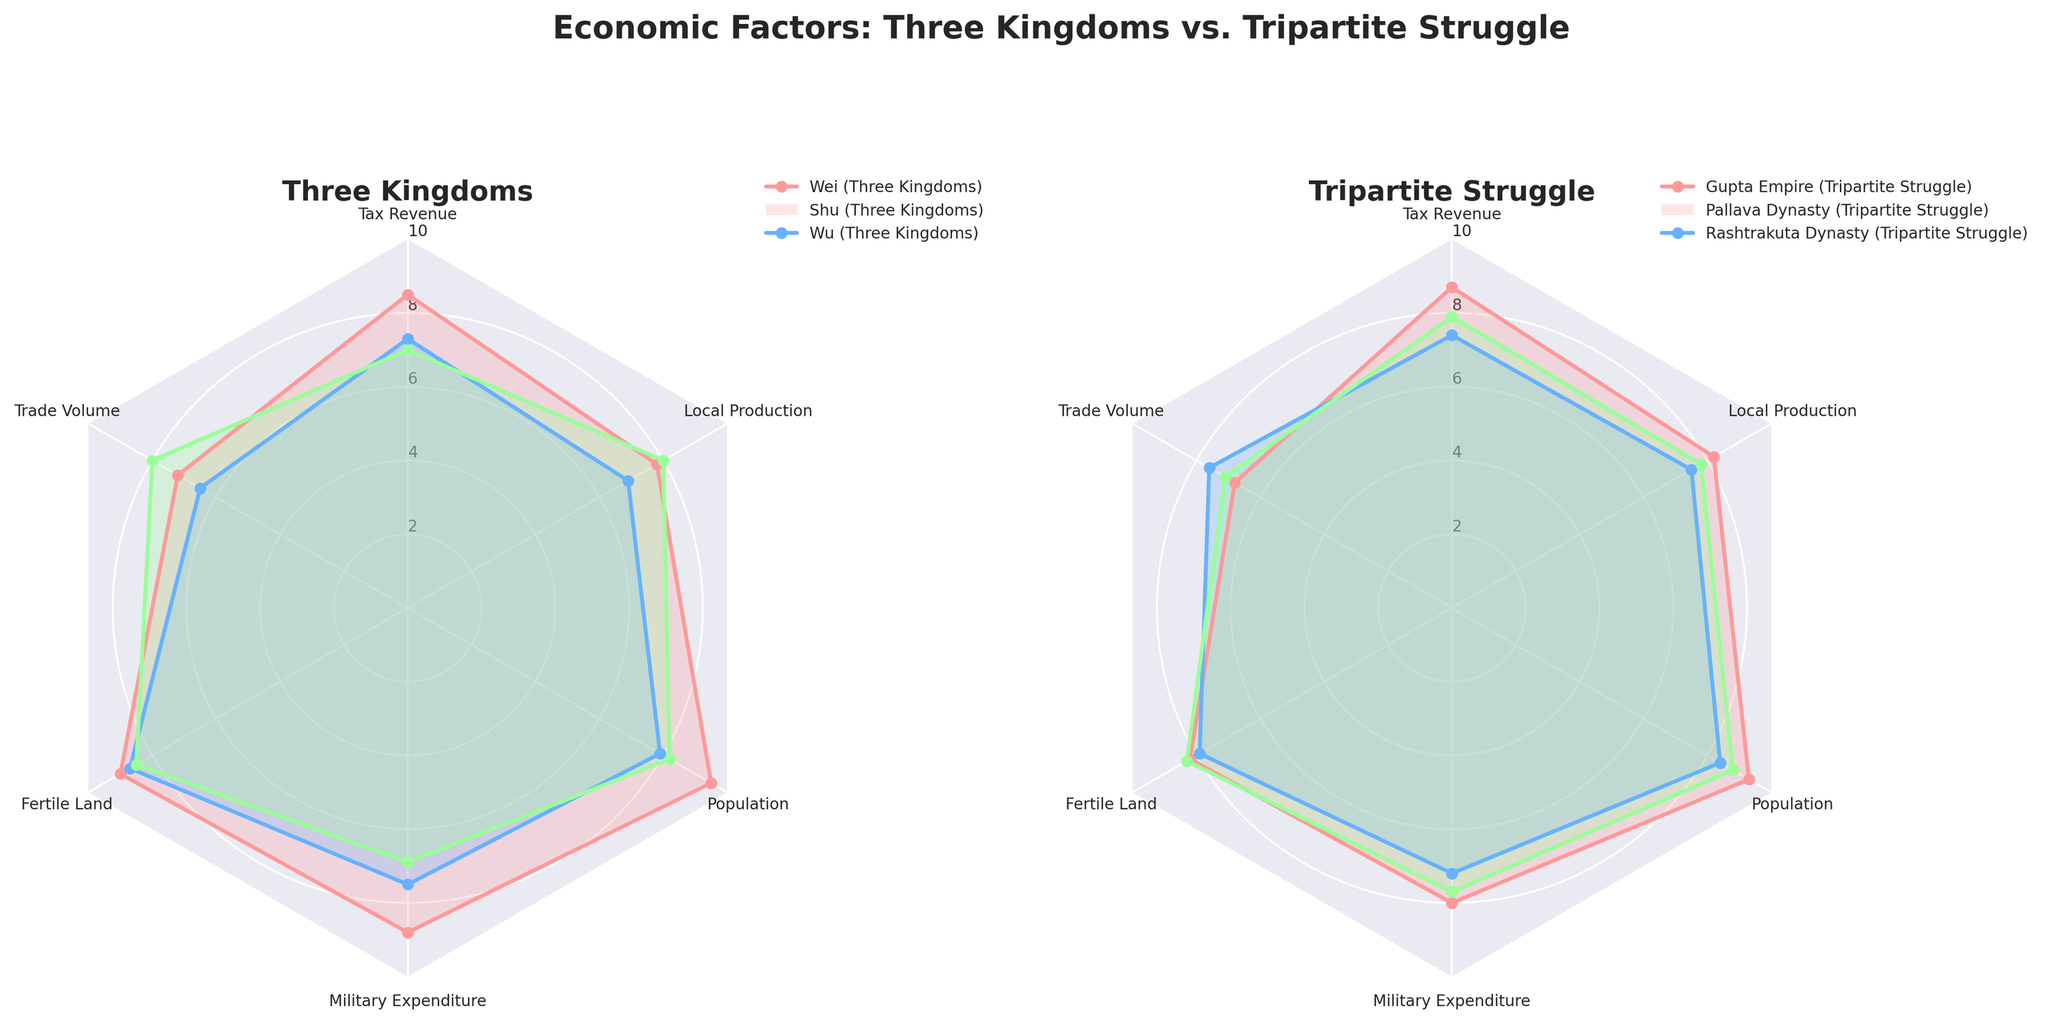What is the title of the figure? The title is typically placed at the top center of the figure and should summarize what the visual represents. For this figure, the title reads "Economic Factors: Three Kingdoms vs. Tripartite Struggle".
Answer: Economic Factors: Three Kingdoms vs. Tripartite Struggle Which kingdom or dynasty has the highest military expenditure? To find the highest military expenditure, look at each plot's military expenditure axes and determine the highest value. Wei in the Three Kingdoms plot has a value of 8.8, which is the highest.
Answer: Wei (Three Kingdoms) What are the six economic factors depicted in the radar charts? The radar charts have labeled axes representing the economic factors. These axes are labeled as follows: Tax Revenue, Trade Volume, Fertile Land, Military Expenditure, Population, and Local Production.
Answer: Tax Revenue, Trade Volume, Fertile Land, Military Expenditure, Population, Local Production How does Shu's trade volume compare to Pallava's trade volume? On the radar chart for Shu, the trade volume is marked at 6.5. Pallava’s trade volume is marked at 7.6. Hence, Pallava's trade volume is higher.
Answer: Pallava's trade volume is higher Which region has the lowest value for Fertile Land? Each region's Fertile Land value can be located on the respective axis. Pallava Dynasty from the Tripartite Struggle has the lowest Fertile Land value at 7.9.
Answer: Pallava Dynasty Among the three entities from both time periods, which has the highest average economic factors? Calculate the average for each of the entities using their values across six economic factors. For Wei: (8.5 + 7.2 + 9.0 + 8.8 + 9.5 + 7.8)/6 = 8.47. For Shu: (7.3 + 6.5 + 8.7 + 7.5 + 7.9 + 6.9)/6 = 7.47. For Wu: (7.0 + 8.0 + 8.5 + 6.9 + 8.2 + 8.0)/6 = 7.77. For Gupta: (8.7 + 6.8 + 8.2 + 8.0 + 9.3 + 8.2)/6 = 8.20. For Pallava: (7.4 + 7.6 + 7.9 + 7.2 + 8.4 + 7.5)/6 = 7.67. For Rashtrakuta: (7.9 + 7.1 + 8.3 + 7.7 + 8.8 + 7.8)/6 = 7.76. Wei has the highest average at 8.47.
Answer: Wei (Three Kingdoms) Which of the Three Kingdoms has the highest local production? Look at the local production axis values in the Three Kingdoms chart. Wu has the highest local production value displayed at 8.0.
Answer: Wu (Three Kingdoms) Compare the population values of Rashtrakuta Dynasty and Shu. Which one is higher? The population values can be found along the population axis of each respective radar chart. Rashtrakuta Dynasty has a population value of 8.8, while Shu has 7.9. Hence, Rashtrakuta Dynasty’s population value is higher.
Answer: Rashtrakuta Dynasty is higher Rank the Tripartite Struggle entities by trade volume. Look at the trade volume axis for the Tripartite Struggle radar chart: Pallava (7.6), Gupta (6.8), Rashtrakuta (7.1). Thus, the ranking from highest to lowest is Pallava, Rashtrakuta, Gupta.
Answer: Pallava > Rashtrakuta > Gupta 